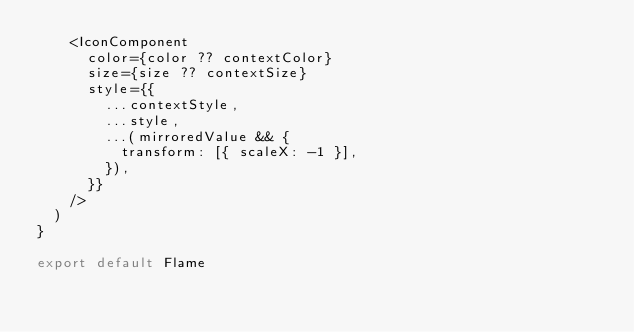Convert code to text. <code><loc_0><loc_0><loc_500><loc_500><_TypeScript_>    <IconComponent
      color={color ?? contextColor}
      size={size ?? contextSize}
      style={{
        ...contextStyle,
        ...style,
        ...(mirroredValue && {
          transform: [{ scaleX: -1 }],
        }),
      }}
    />
  )
}

export default Flame
  </code> 